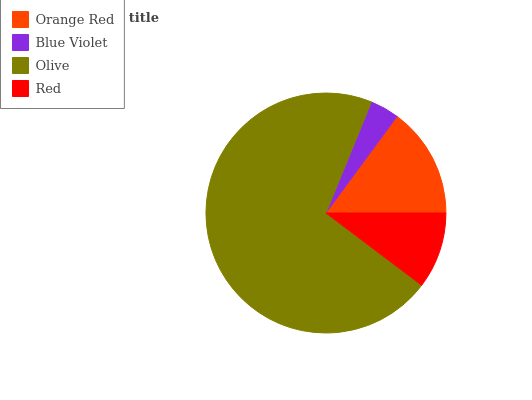Is Blue Violet the minimum?
Answer yes or no. Yes. Is Olive the maximum?
Answer yes or no. Yes. Is Olive the minimum?
Answer yes or no. No. Is Blue Violet the maximum?
Answer yes or no. No. Is Olive greater than Blue Violet?
Answer yes or no. Yes. Is Blue Violet less than Olive?
Answer yes or no. Yes. Is Blue Violet greater than Olive?
Answer yes or no. No. Is Olive less than Blue Violet?
Answer yes or no. No. Is Orange Red the high median?
Answer yes or no. Yes. Is Red the low median?
Answer yes or no. Yes. Is Olive the high median?
Answer yes or no. No. Is Orange Red the low median?
Answer yes or no. No. 